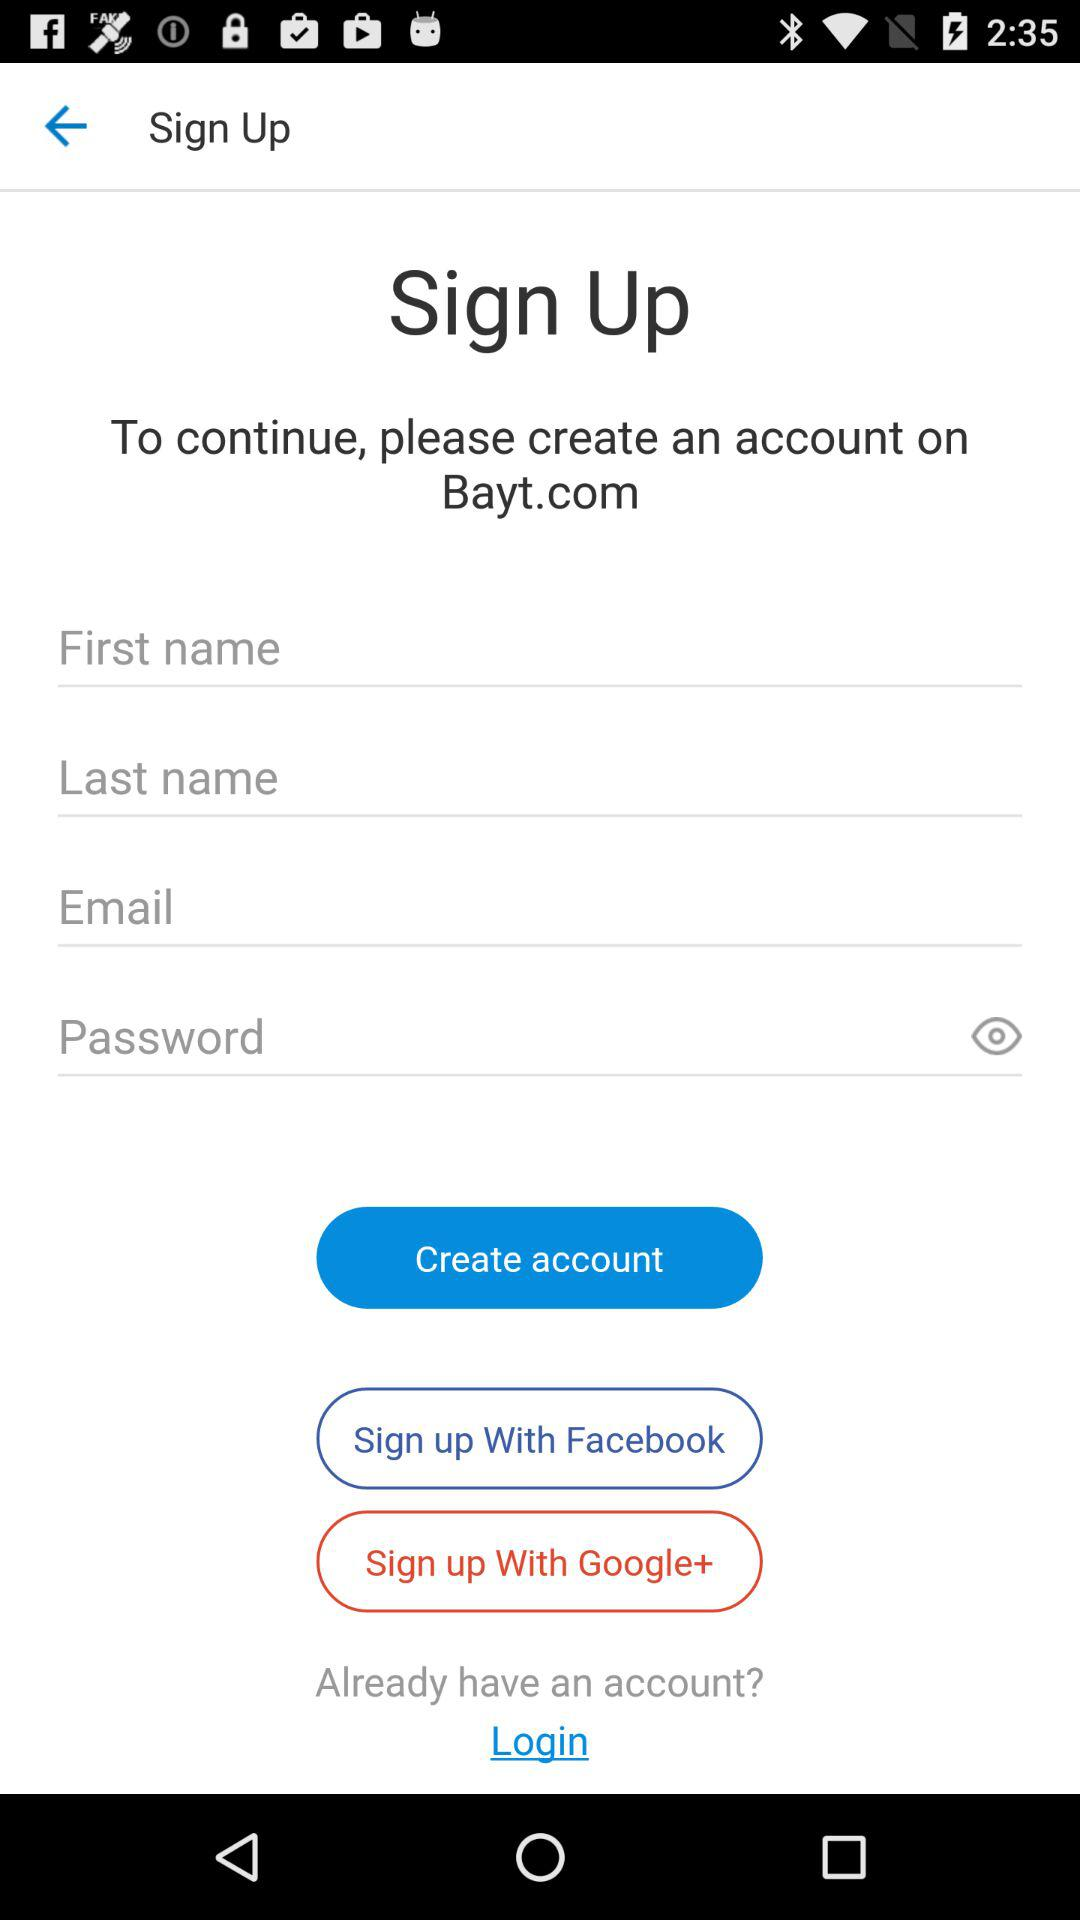How many text fields are there in this sign up form?
Answer the question using a single word or phrase. 4 